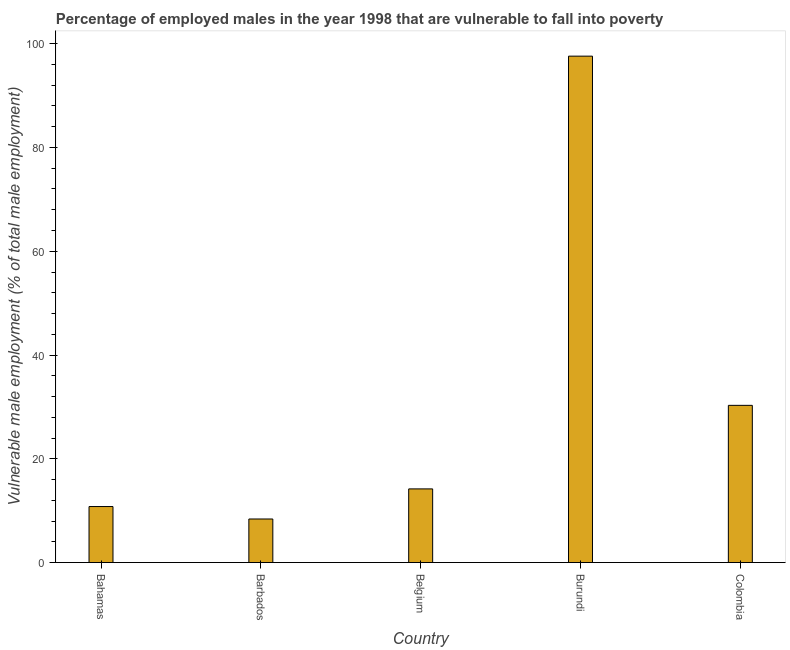What is the title of the graph?
Make the answer very short. Percentage of employed males in the year 1998 that are vulnerable to fall into poverty. What is the label or title of the X-axis?
Ensure brevity in your answer.  Country. What is the label or title of the Y-axis?
Your answer should be compact. Vulnerable male employment (% of total male employment). What is the percentage of employed males who are vulnerable to fall into poverty in Bahamas?
Ensure brevity in your answer.  10.8. Across all countries, what is the maximum percentage of employed males who are vulnerable to fall into poverty?
Your answer should be compact. 97.6. Across all countries, what is the minimum percentage of employed males who are vulnerable to fall into poverty?
Offer a very short reply. 8.4. In which country was the percentage of employed males who are vulnerable to fall into poverty maximum?
Make the answer very short. Burundi. In which country was the percentage of employed males who are vulnerable to fall into poverty minimum?
Offer a terse response. Barbados. What is the sum of the percentage of employed males who are vulnerable to fall into poverty?
Give a very brief answer. 161.3. What is the difference between the percentage of employed males who are vulnerable to fall into poverty in Bahamas and Belgium?
Keep it short and to the point. -3.4. What is the average percentage of employed males who are vulnerable to fall into poverty per country?
Offer a terse response. 32.26. What is the median percentage of employed males who are vulnerable to fall into poverty?
Give a very brief answer. 14.2. In how many countries, is the percentage of employed males who are vulnerable to fall into poverty greater than 44 %?
Your answer should be compact. 1. What is the ratio of the percentage of employed males who are vulnerable to fall into poverty in Belgium to that in Burundi?
Give a very brief answer. 0.14. What is the difference between the highest and the second highest percentage of employed males who are vulnerable to fall into poverty?
Ensure brevity in your answer.  67.3. Is the sum of the percentage of employed males who are vulnerable to fall into poverty in Barbados and Burundi greater than the maximum percentage of employed males who are vulnerable to fall into poverty across all countries?
Offer a terse response. Yes. What is the difference between the highest and the lowest percentage of employed males who are vulnerable to fall into poverty?
Provide a succinct answer. 89.2. How many countries are there in the graph?
Your answer should be very brief. 5. What is the difference between two consecutive major ticks on the Y-axis?
Make the answer very short. 20. Are the values on the major ticks of Y-axis written in scientific E-notation?
Offer a very short reply. No. What is the Vulnerable male employment (% of total male employment) of Bahamas?
Give a very brief answer. 10.8. What is the Vulnerable male employment (% of total male employment) of Barbados?
Your answer should be very brief. 8.4. What is the Vulnerable male employment (% of total male employment) of Belgium?
Your answer should be compact. 14.2. What is the Vulnerable male employment (% of total male employment) in Burundi?
Ensure brevity in your answer.  97.6. What is the Vulnerable male employment (% of total male employment) of Colombia?
Your answer should be very brief. 30.3. What is the difference between the Vulnerable male employment (% of total male employment) in Bahamas and Barbados?
Keep it short and to the point. 2.4. What is the difference between the Vulnerable male employment (% of total male employment) in Bahamas and Burundi?
Provide a succinct answer. -86.8. What is the difference between the Vulnerable male employment (% of total male employment) in Bahamas and Colombia?
Provide a succinct answer. -19.5. What is the difference between the Vulnerable male employment (% of total male employment) in Barbados and Burundi?
Provide a short and direct response. -89.2. What is the difference between the Vulnerable male employment (% of total male employment) in Barbados and Colombia?
Provide a short and direct response. -21.9. What is the difference between the Vulnerable male employment (% of total male employment) in Belgium and Burundi?
Provide a succinct answer. -83.4. What is the difference between the Vulnerable male employment (% of total male employment) in Belgium and Colombia?
Offer a very short reply. -16.1. What is the difference between the Vulnerable male employment (% of total male employment) in Burundi and Colombia?
Your response must be concise. 67.3. What is the ratio of the Vulnerable male employment (% of total male employment) in Bahamas to that in Barbados?
Provide a succinct answer. 1.29. What is the ratio of the Vulnerable male employment (% of total male employment) in Bahamas to that in Belgium?
Your answer should be very brief. 0.76. What is the ratio of the Vulnerable male employment (% of total male employment) in Bahamas to that in Burundi?
Your answer should be very brief. 0.11. What is the ratio of the Vulnerable male employment (% of total male employment) in Bahamas to that in Colombia?
Keep it short and to the point. 0.36. What is the ratio of the Vulnerable male employment (% of total male employment) in Barbados to that in Belgium?
Give a very brief answer. 0.59. What is the ratio of the Vulnerable male employment (% of total male employment) in Barbados to that in Burundi?
Keep it short and to the point. 0.09. What is the ratio of the Vulnerable male employment (% of total male employment) in Barbados to that in Colombia?
Offer a terse response. 0.28. What is the ratio of the Vulnerable male employment (% of total male employment) in Belgium to that in Burundi?
Offer a terse response. 0.14. What is the ratio of the Vulnerable male employment (% of total male employment) in Belgium to that in Colombia?
Offer a very short reply. 0.47. What is the ratio of the Vulnerable male employment (% of total male employment) in Burundi to that in Colombia?
Offer a terse response. 3.22. 